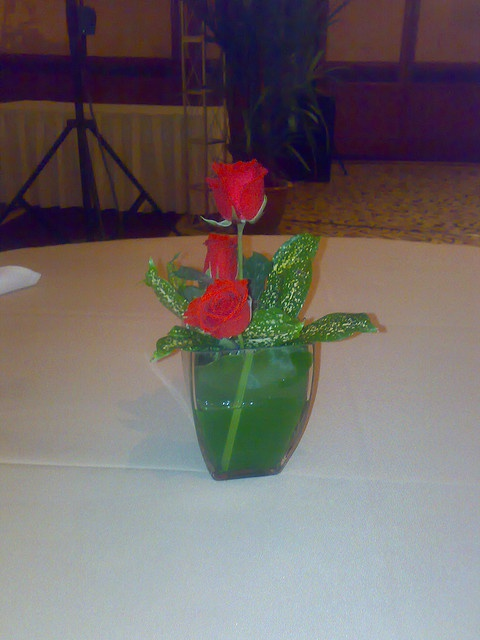Describe the objects in this image and their specific colors. I can see dining table in maroon, darkgray, and gray tones and vase in maroon, darkgreen, and teal tones in this image. 